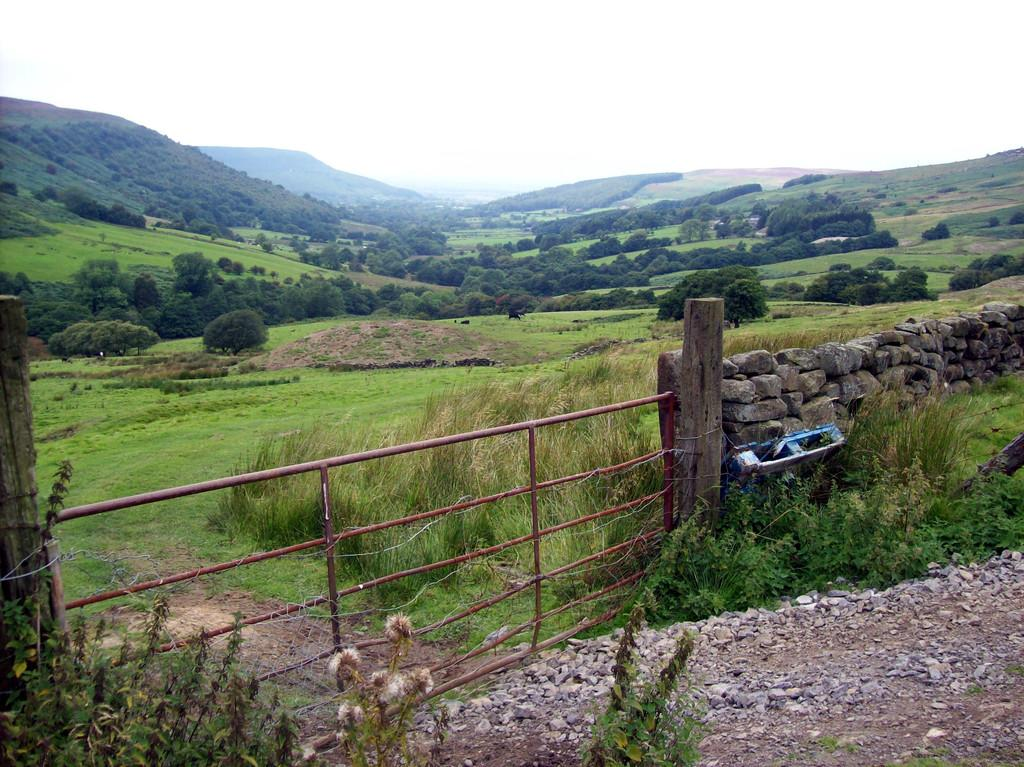What type of structure can be seen in the image? There is a stone wall in the image. What other materials are present in the image? Wooden poles and a fence can be seen in the image. What type of natural environment is depicted in the image? Trees, grass, plants, and mountains are visible in the image. What is the background of the image? The sky is visible in the background of the image. What type of mine can be seen in the image? There is no mine present in the image. What type of home is visible in the image? There is no home visible in the image. 